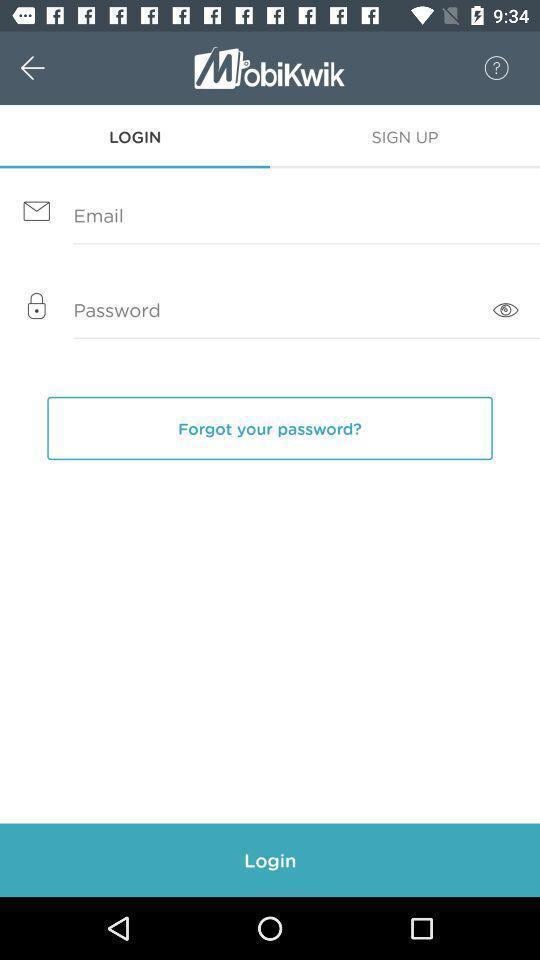Describe the key features of this screenshot. Login page. 